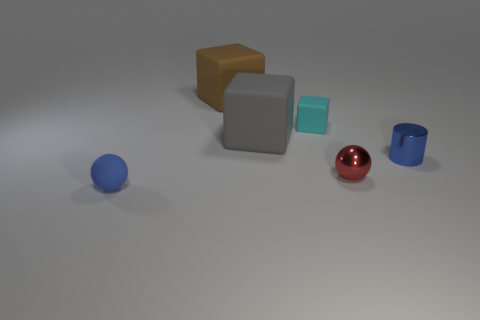Add 1 tiny brown rubber things. How many objects exist? 7 Subtract all small cyan rubber blocks. How many blocks are left? 2 Subtract all blue blocks. How many blue balls are left? 1 Subtract all small green metal cylinders. Subtract all blue metallic cylinders. How many objects are left? 5 Add 5 small red spheres. How many small red spheres are left? 6 Add 3 brown rubber objects. How many brown rubber objects exist? 4 Subtract all red spheres. How many spheres are left? 1 Subtract 0 yellow cylinders. How many objects are left? 6 Subtract all cylinders. How many objects are left? 5 Subtract 1 balls. How many balls are left? 1 